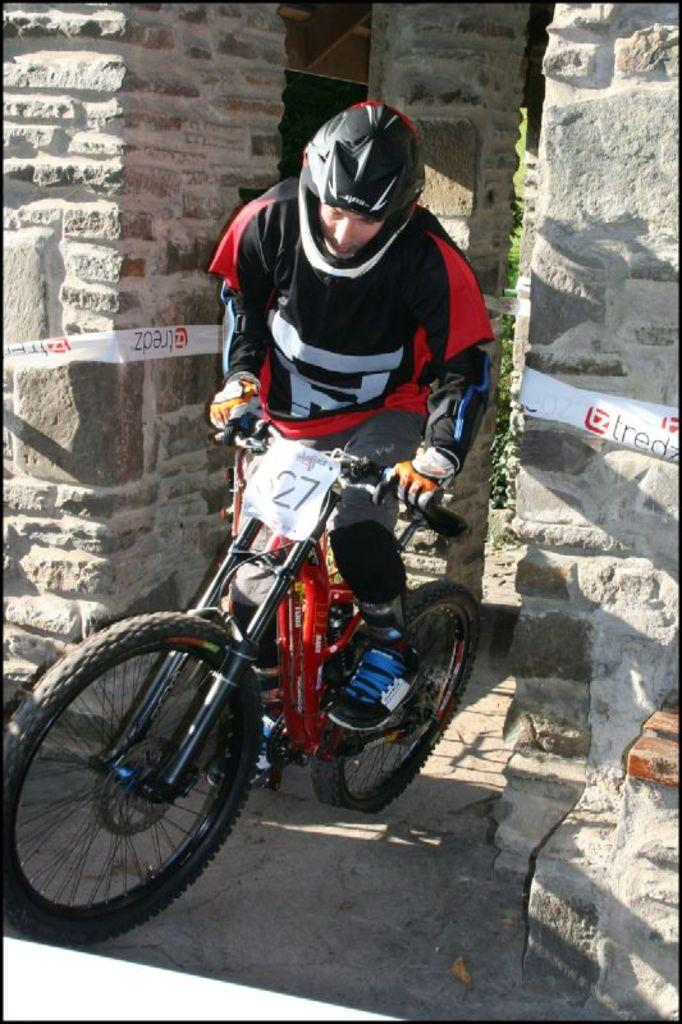Who is the main subject in the image? There is a man in the image. What is the man doing in the image? The man is riding a bicycle. What architectural features can be seen in the image? There are pillars visible in the image. What type of mass can be seen floating in the basin in the image? There is no basin or mass present in the image; it features a man riding a bicycle and pillars. 